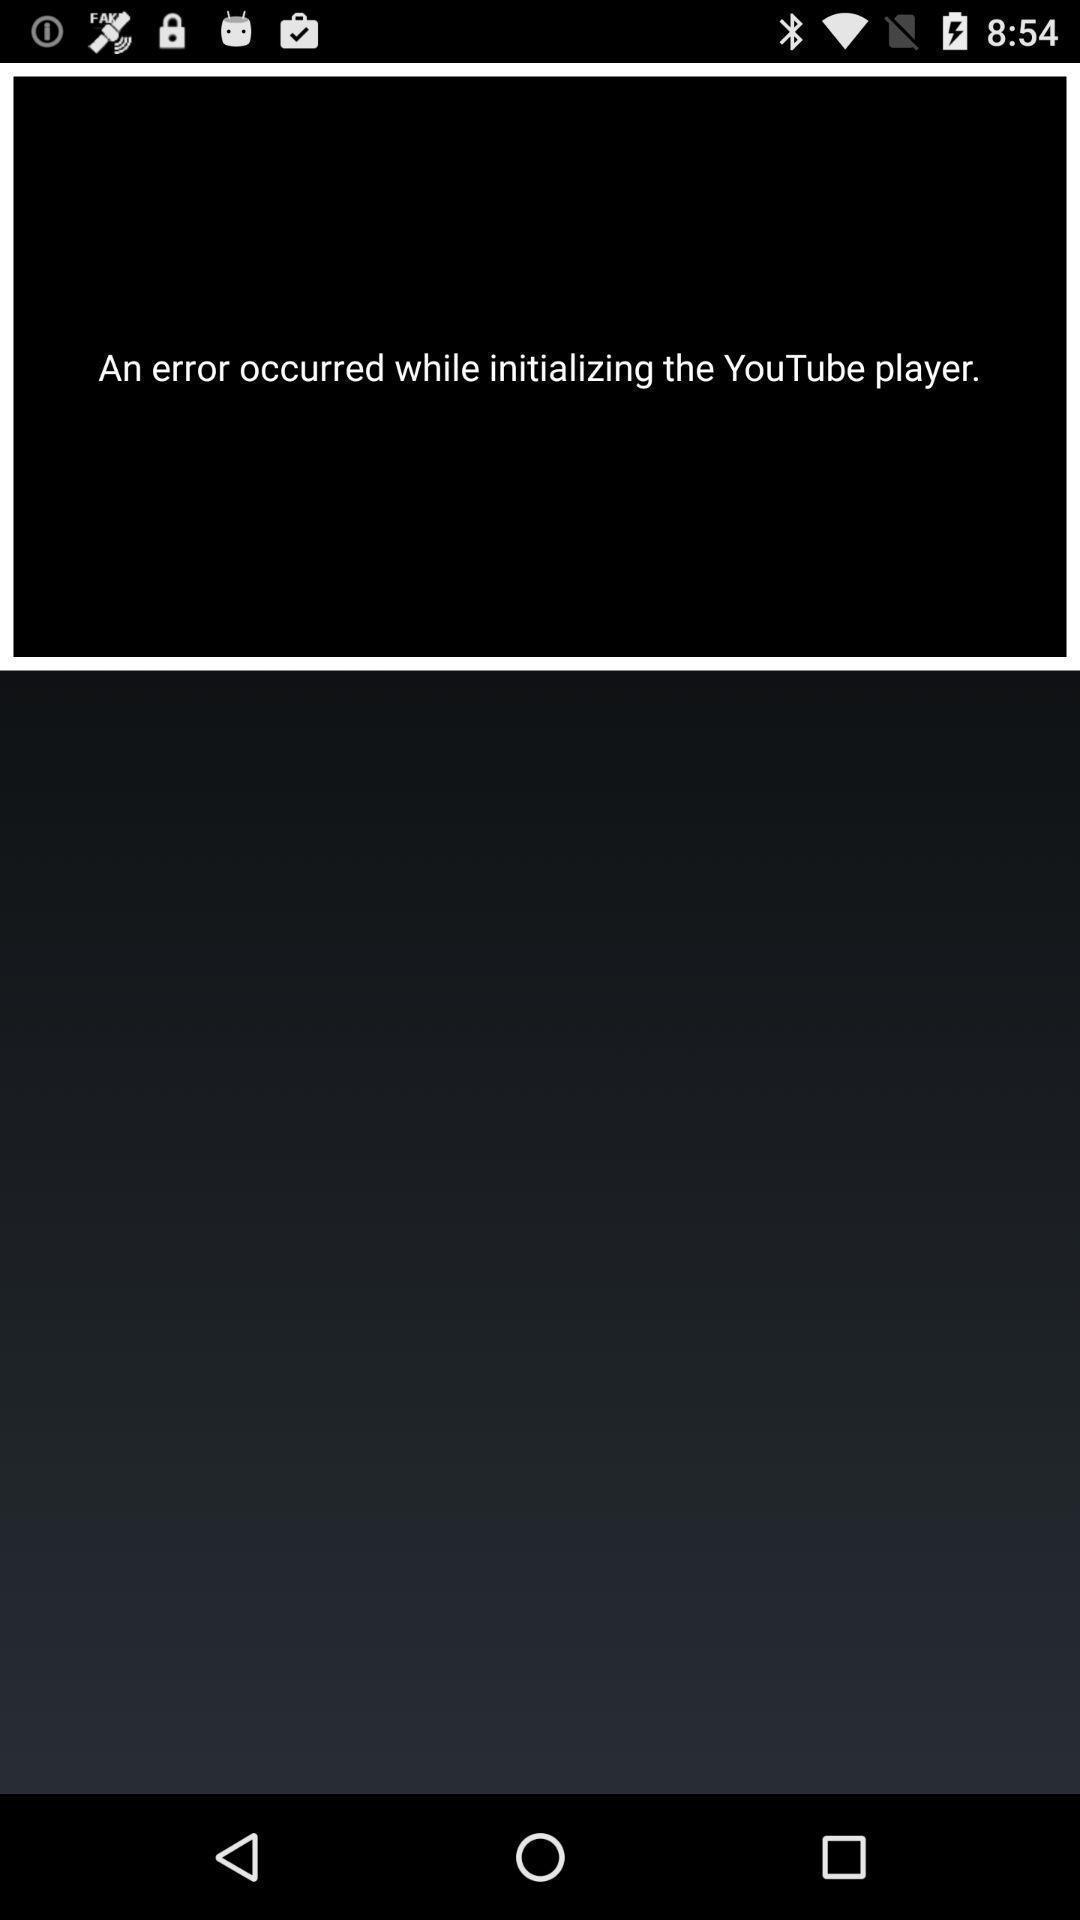Provide a textual representation of this image. Screen displaying an error message. 